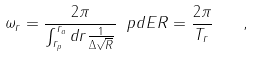<formula> <loc_0><loc_0><loc_500><loc_500>\omega _ { r } = \frac { 2 \pi } { \int _ { r _ { p } } ^ { r _ { a } } d r \frac { 1 } { \Delta \sqrt { R } } } \ p d { E } { R } = \frac { 2 \pi } { T _ { r } } \quad ,</formula> 